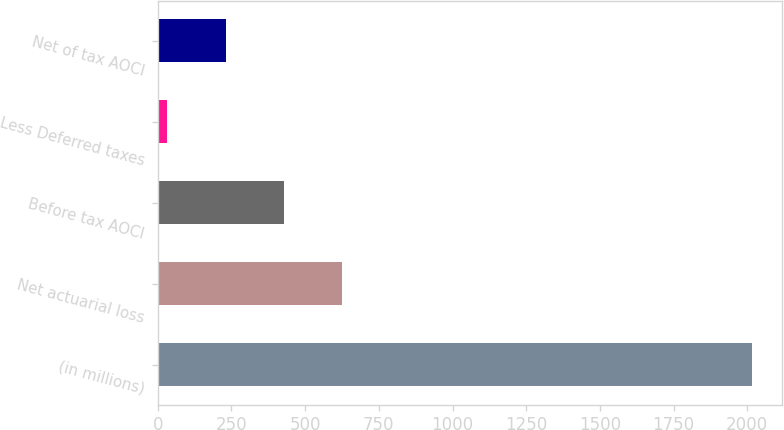Convert chart. <chart><loc_0><loc_0><loc_500><loc_500><bar_chart><fcel>(in millions)<fcel>Net actuarial loss<fcel>Before tax AOCI<fcel>Less Deferred taxes<fcel>Net of tax AOCI<nl><fcel>2016<fcel>626.64<fcel>428.16<fcel>31.2<fcel>229.68<nl></chart> 